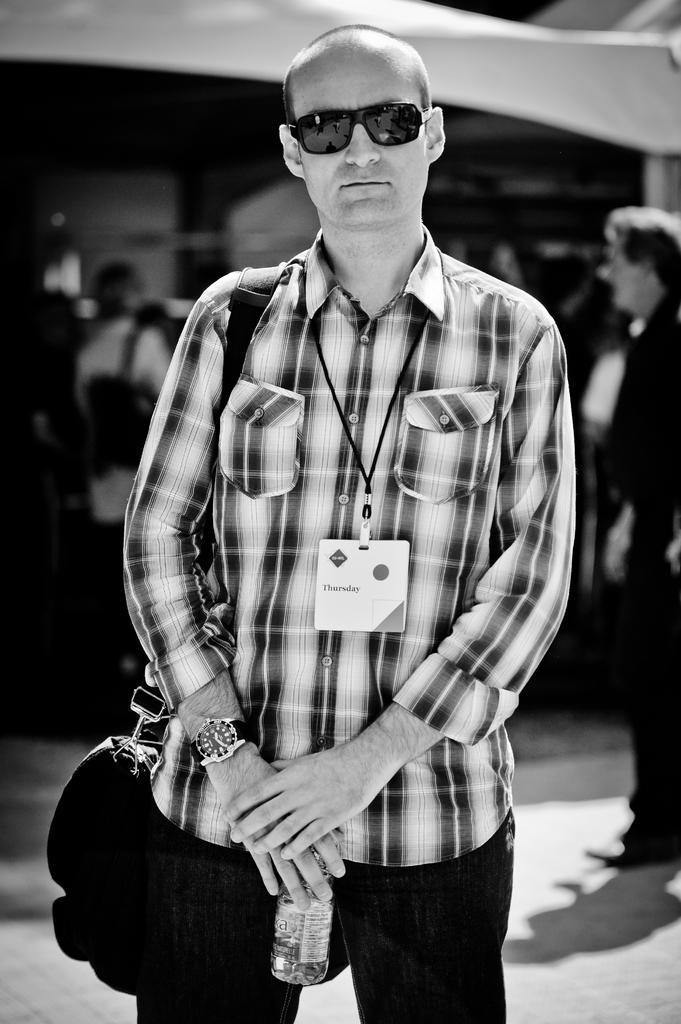In one or two sentences, can you explain what this image depicts? In this image I can see the person is wearing the bag and holding the bottle. Background is blurred and the image is in black and white. 